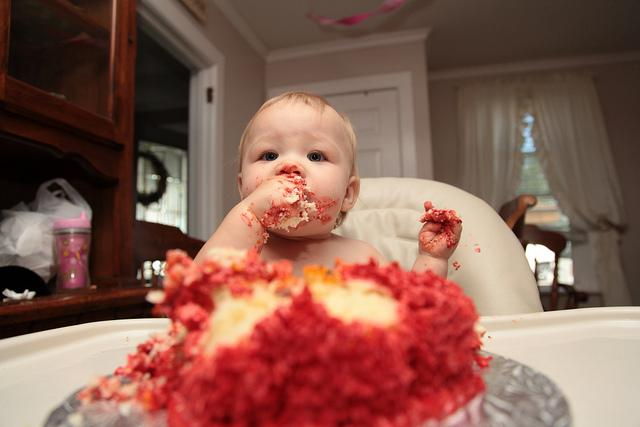What's the baby done to get so messy? eat cake 